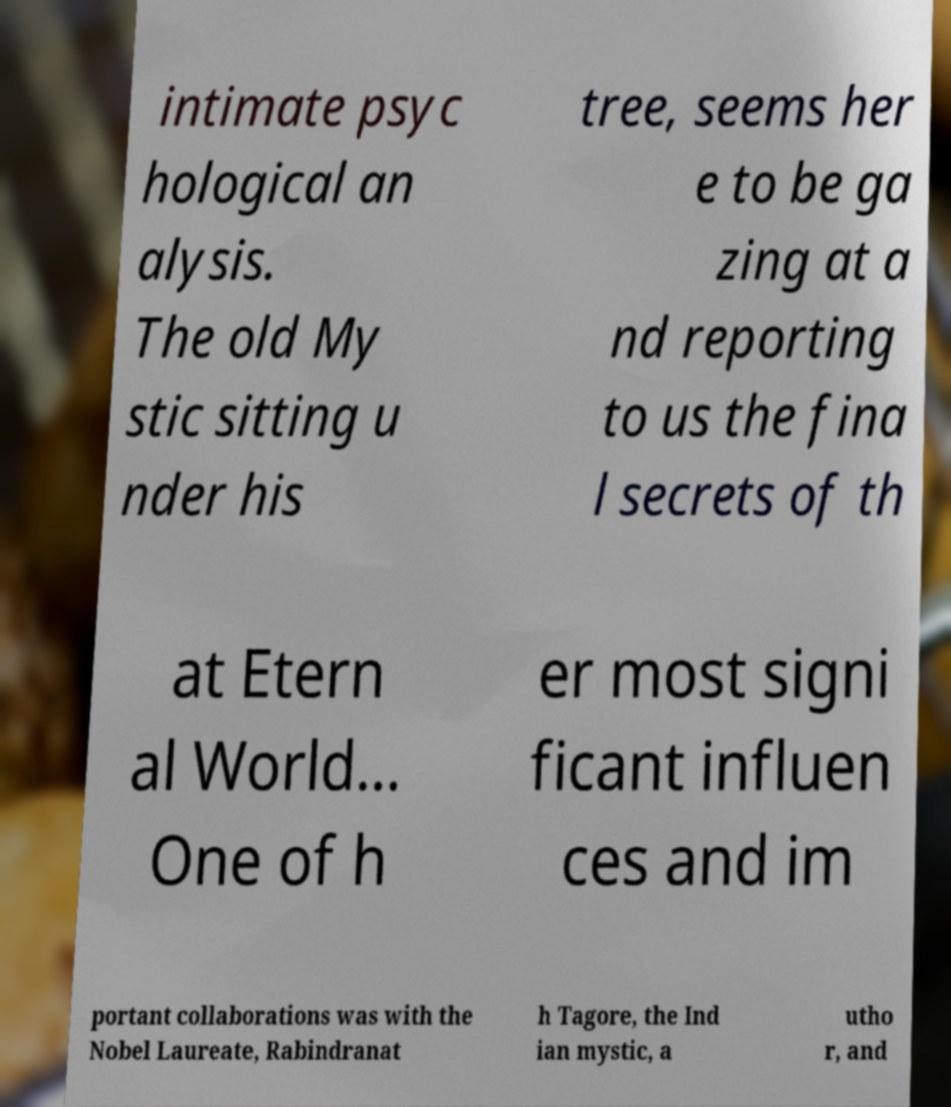Please read and relay the text visible in this image. What does it say? intimate psyc hological an alysis. The old My stic sitting u nder his tree, seems her e to be ga zing at a nd reporting to us the fina l secrets of th at Etern al World... One of h er most signi ficant influen ces and im portant collaborations was with the Nobel Laureate, Rabindranat h Tagore, the Ind ian mystic, a utho r, and 